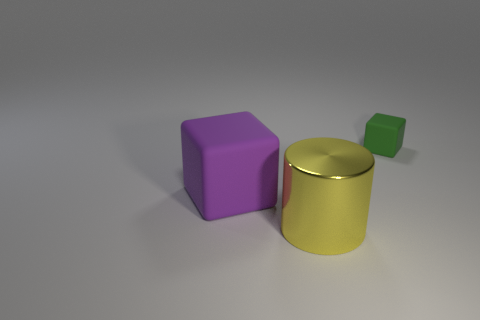Add 3 large yellow metallic things. How many objects exist? 6 Subtract all cylinders. How many objects are left? 2 Subtract all purple blocks. Subtract all small objects. How many objects are left? 1 Add 2 tiny green matte things. How many tiny green matte things are left? 3 Add 2 brown metal blocks. How many brown metal blocks exist? 2 Subtract 1 purple blocks. How many objects are left? 2 